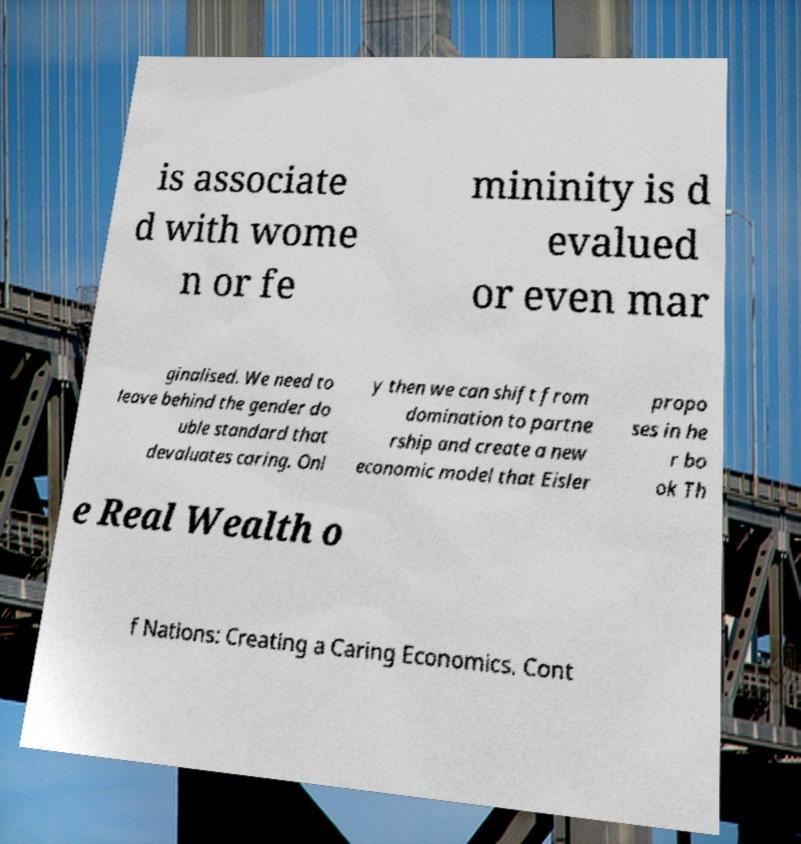Could you extract and type out the text from this image? is associate d with wome n or fe mininity is d evalued or even mar ginalised. We need to leave behind the gender do uble standard that devaluates caring. Onl y then we can shift from domination to partne rship and create a new economic model that Eisler propo ses in he r bo ok Th e Real Wealth o f Nations: Creating a Caring Economics. Cont 